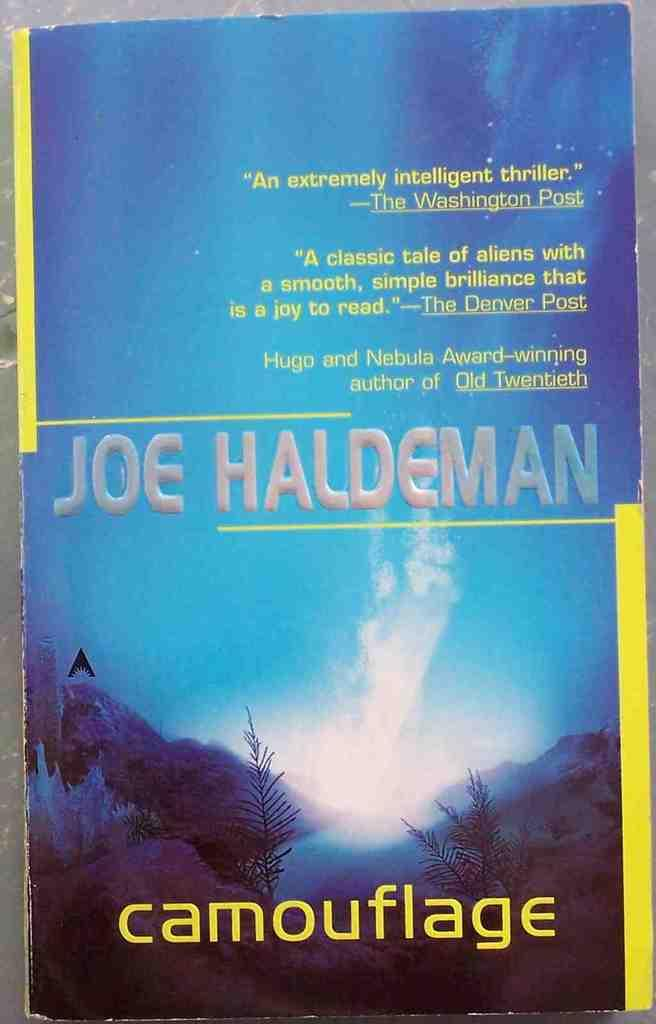<image>
Provide a brief description of the given image. The Washington Post says that the book Camouflage is intelligent. 